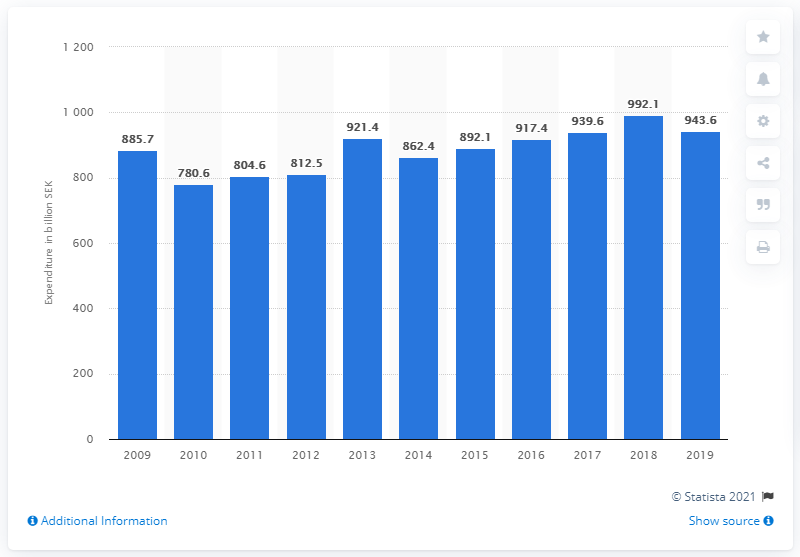Specify some key components in this picture. In 2019, the central government expenditure in Sweden was 943.6 billion. In 2018, Sweden's highest expenditure was 992.1 billion SEK. 